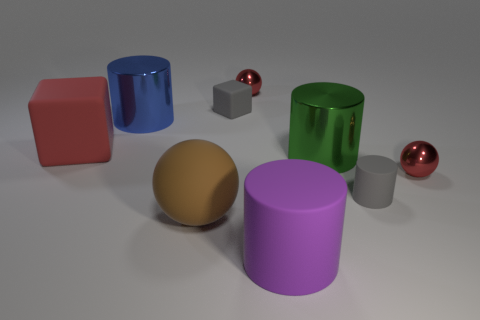Are any tiny rubber things visible?
Offer a terse response. Yes. What is the red thing that is both to the right of the big brown object and left of the purple thing made of?
Keep it short and to the point. Metal. Are there more tiny gray rubber blocks behind the gray matte block than big green metallic cylinders that are in front of the brown matte thing?
Make the answer very short. No. Are there any gray cylinders of the same size as the red rubber object?
Offer a terse response. No. There is a metallic ball to the right of the red shiny thing behind the red metallic object that is in front of the small cube; what is its size?
Make the answer very short. Small. The large ball is what color?
Offer a terse response. Brown. Is the number of large blue cylinders on the right side of the large green metal thing greater than the number of tiny rubber cylinders?
Provide a succinct answer. No. There is a large purple rubber cylinder; how many metal objects are to the right of it?
Your answer should be compact. 2. There is a small rubber object that is the same color as the small matte block; what shape is it?
Offer a terse response. Cylinder. There is a metal sphere behind the gray matte thing that is behind the red matte thing; is there a big rubber thing right of it?
Your answer should be compact. Yes. 